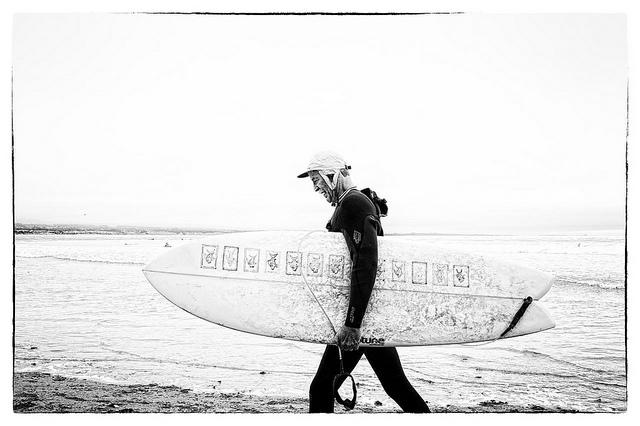Are the waves in the picture big enough to surfboard?
Write a very short answer. No. What is the man holding in his arm?
Be succinct. Surfboard. How old is the main person in this picture?
Short answer required. 40. 